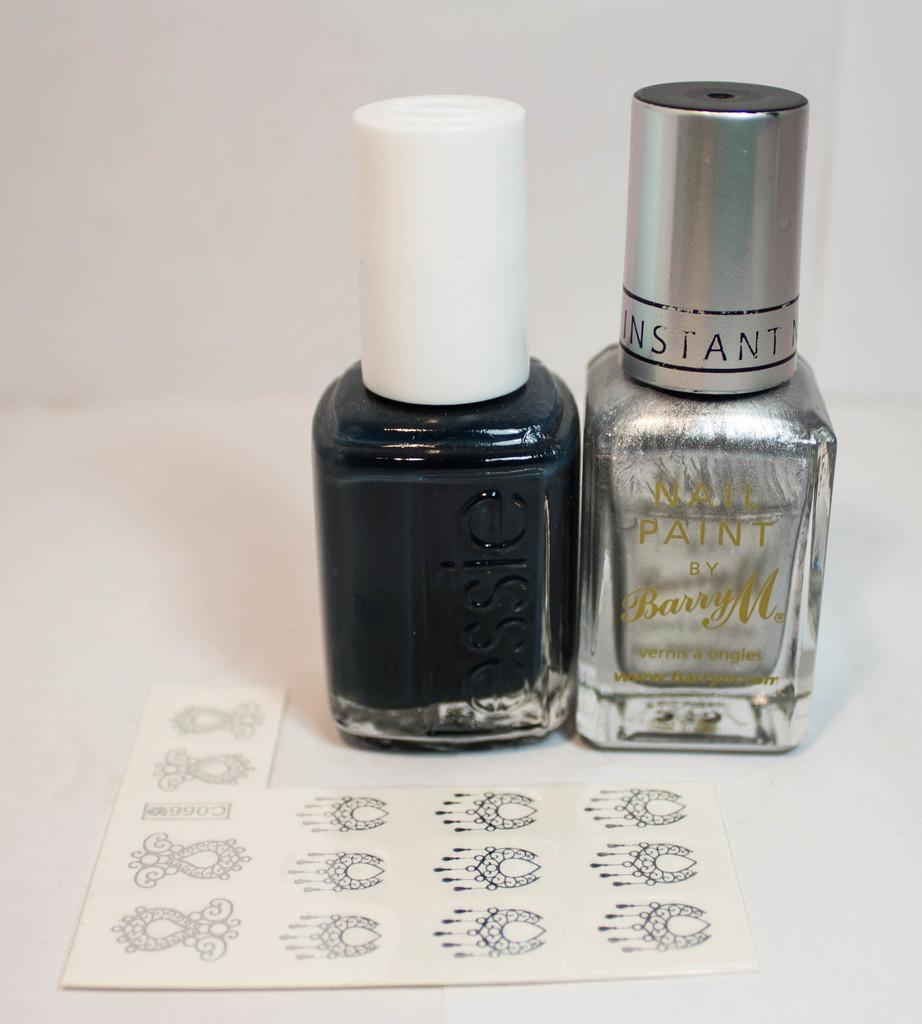<image>
Share a concise interpretation of the image provided. Two bottles of nail polish are next to each other and one bottle says "essie". 